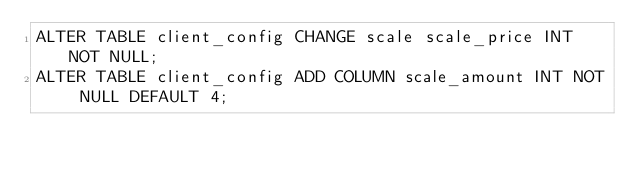<code> <loc_0><loc_0><loc_500><loc_500><_SQL_>ALTER TABLE client_config CHANGE scale scale_price INT NOT NULL;
ALTER TABLE client_config ADD COLUMN scale_amount INT NOT NULL DEFAULT 4;
</code> 